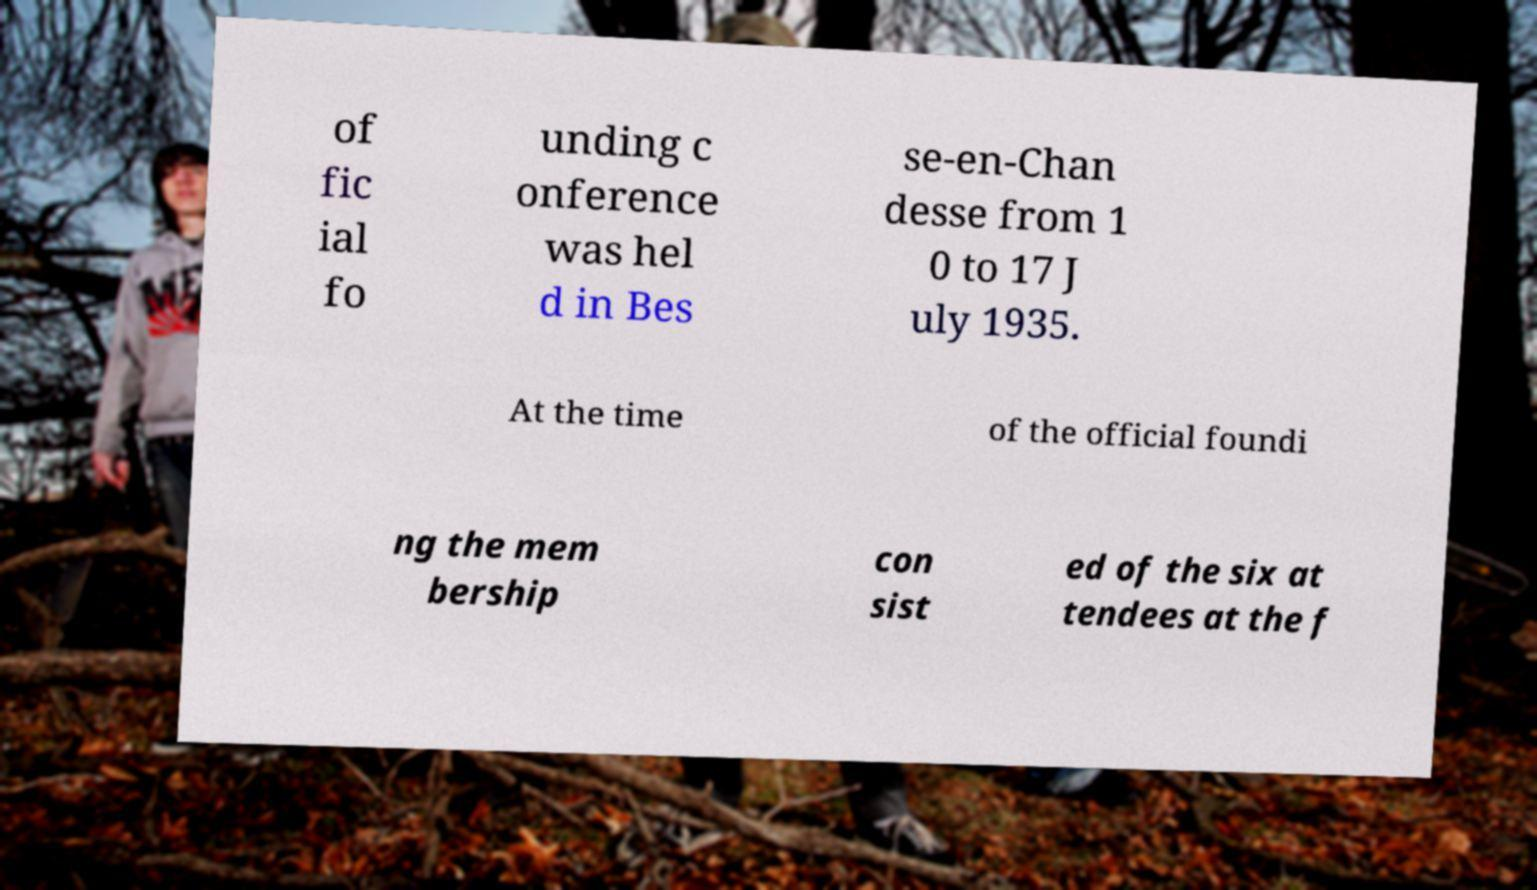Can you accurately transcribe the text from the provided image for me? of fic ial fo unding c onference was hel d in Bes se-en-Chan desse from 1 0 to 17 J uly 1935. At the time of the official foundi ng the mem bership con sist ed of the six at tendees at the f 